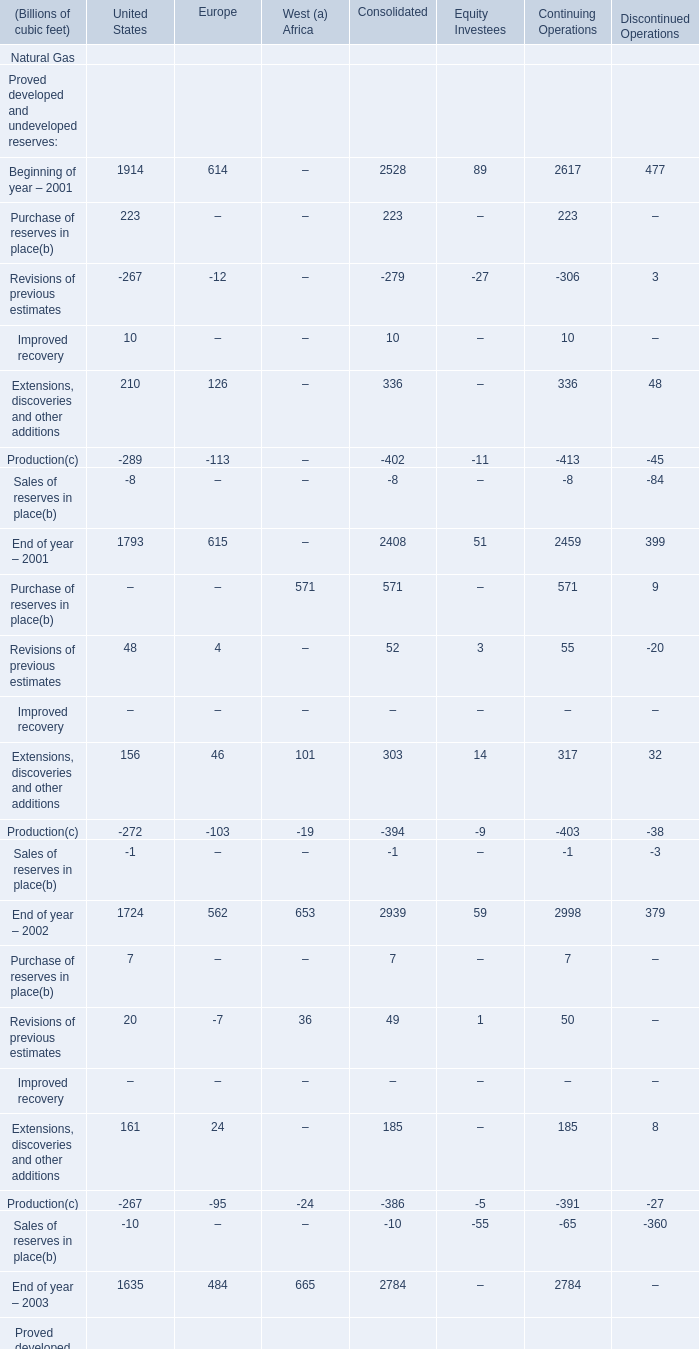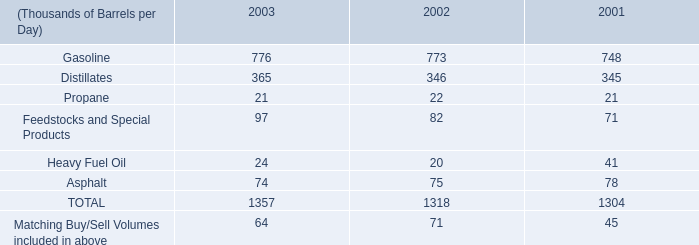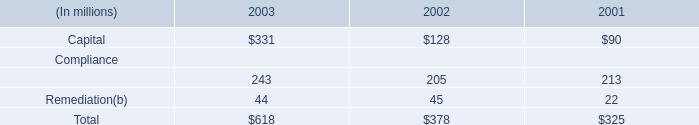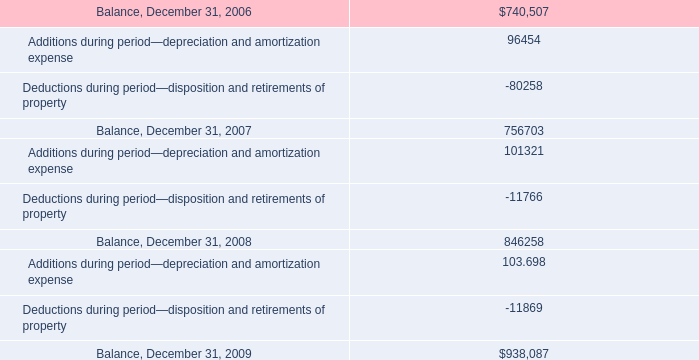what was map's 3 year growth of gasoline production? 
Computations: ((776 - 748) / 748)
Answer: 0.03743. 